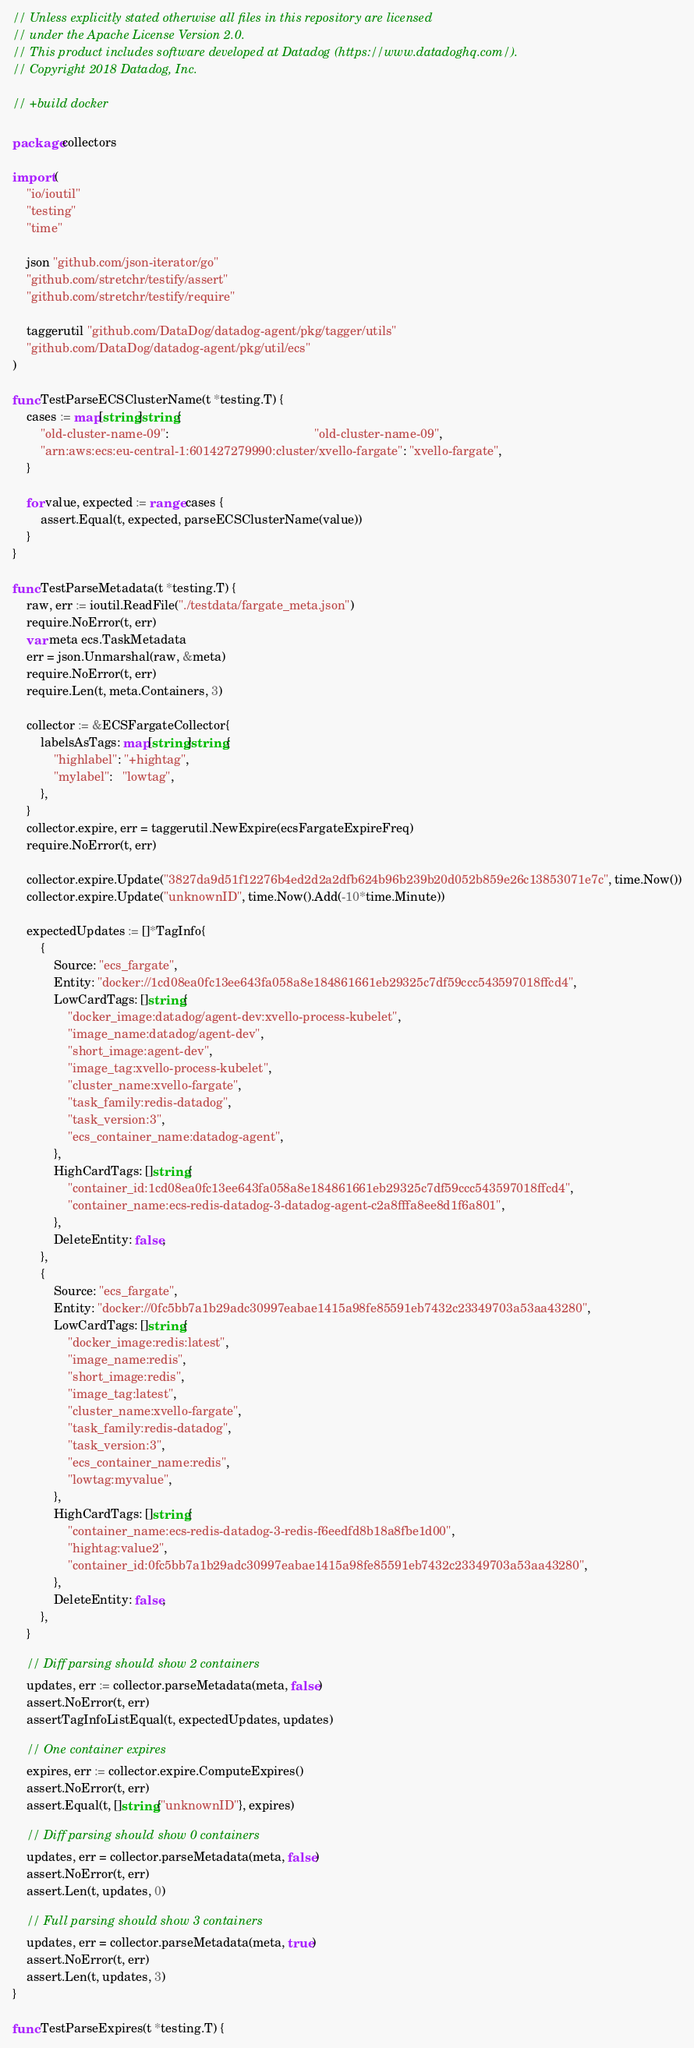<code> <loc_0><loc_0><loc_500><loc_500><_Go_>// Unless explicitly stated otherwise all files in this repository are licensed
// under the Apache License Version 2.0.
// This product includes software developed at Datadog (https://www.datadoghq.com/).
// Copyright 2018 Datadog, Inc.

// +build docker

package collectors

import (
	"io/ioutil"
	"testing"
	"time"

	json "github.com/json-iterator/go"
	"github.com/stretchr/testify/assert"
	"github.com/stretchr/testify/require"

	taggerutil "github.com/DataDog/datadog-agent/pkg/tagger/utils"
	"github.com/DataDog/datadog-agent/pkg/util/ecs"
)

func TestParseECSClusterName(t *testing.T) {
	cases := map[string]string{
		"old-cluster-name-09":                                          "old-cluster-name-09",
		"arn:aws:ecs:eu-central-1:601427279990:cluster/xvello-fargate": "xvello-fargate",
	}

	for value, expected := range cases {
		assert.Equal(t, expected, parseECSClusterName(value))
	}
}

func TestParseMetadata(t *testing.T) {
	raw, err := ioutil.ReadFile("./testdata/fargate_meta.json")
	require.NoError(t, err)
	var meta ecs.TaskMetadata
	err = json.Unmarshal(raw, &meta)
	require.NoError(t, err)
	require.Len(t, meta.Containers, 3)

	collector := &ECSFargateCollector{
		labelsAsTags: map[string]string{
			"highlabel": "+hightag",
			"mylabel":   "lowtag",
		},
	}
	collector.expire, err = taggerutil.NewExpire(ecsFargateExpireFreq)
	require.NoError(t, err)

	collector.expire.Update("3827da9d51f12276b4ed2d2a2dfb624b96b239b20d052b859e26c13853071e7c", time.Now())
	collector.expire.Update("unknownID", time.Now().Add(-10*time.Minute))

	expectedUpdates := []*TagInfo{
		{
			Source: "ecs_fargate",
			Entity: "docker://1cd08ea0fc13ee643fa058a8e184861661eb29325c7df59ccc543597018ffcd4",
			LowCardTags: []string{
				"docker_image:datadog/agent-dev:xvello-process-kubelet",
				"image_name:datadog/agent-dev",
				"short_image:agent-dev",
				"image_tag:xvello-process-kubelet",
				"cluster_name:xvello-fargate",
				"task_family:redis-datadog",
				"task_version:3",
				"ecs_container_name:datadog-agent",
			},
			HighCardTags: []string{
				"container_id:1cd08ea0fc13ee643fa058a8e184861661eb29325c7df59ccc543597018ffcd4",
				"container_name:ecs-redis-datadog-3-datadog-agent-c2a8fffa8ee8d1f6a801",
			},
			DeleteEntity: false,
		},
		{
			Source: "ecs_fargate",
			Entity: "docker://0fc5bb7a1b29adc30997eabae1415a98fe85591eb7432c23349703a53aa43280",
			LowCardTags: []string{
				"docker_image:redis:latest",
				"image_name:redis",
				"short_image:redis",
				"image_tag:latest",
				"cluster_name:xvello-fargate",
				"task_family:redis-datadog",
				"task_version:3",
				"ecs_container_name:redis",
				"lowtag:myvalue",
			},
			HighCardTags: []string{
				"container_name:ecs-redis-datadog-3-redis-f6eedfd8b18a8fbe1d00",
				"hightag:value2",
				"container_id:0fc5bb7a1b29adc30997eabae1415a98fe85591eb7432c23349703a53aa43280",
			},
			DeleteEntity: false,
		},
	}

	// Diff parsing should show 2 containers
	updates, err := collector.parseMetadata(meta, false)
	assert.NoError(t, err)
	assertTagInfoListEqual(t, expectedUpdates, updates)

	// One container expires
	expires, err := collector.expire.ComputeExpires()
	assert.NoError(t, err)
	assert.Equal(t, []string{"unknownID"}, expires)

	// Diff parsing should show 0 containers
	updates, err = collector.parseMetadata(meta, false)
	assert.NoError(t, err)
	assert.Len(t, updates, 0)

	// Full parsing should show 3 containers
	updates, err = collector.parseMetadata(meta, true)
	assert.NoError(t, err)
	assert.Len(t, updates, 3)
}

func TestParseExpires(t *testing.T) {</code> 